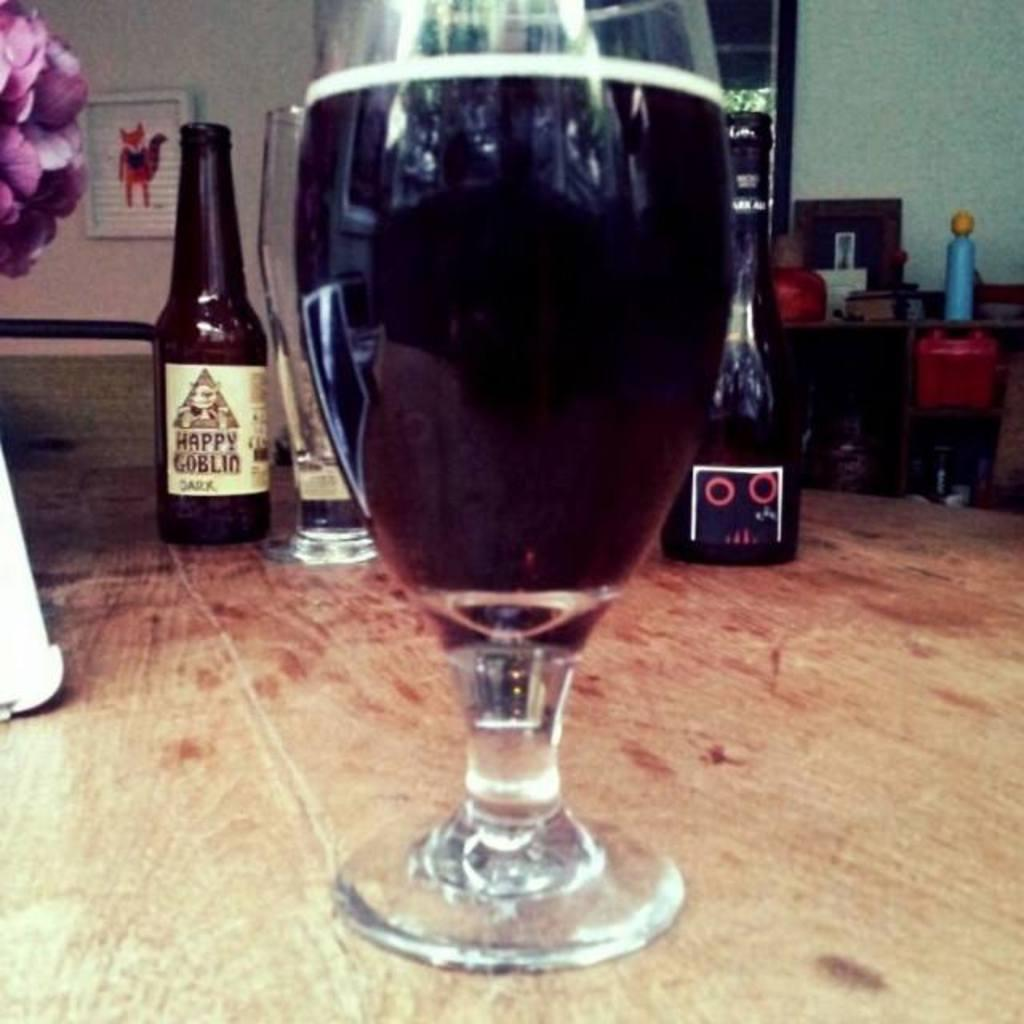What type of containers are present in the image? There are bottles in the image. What type of glassware is present in the image? There is a wine glass in the image. Where are the bottles and wine glass located in the image? Both the bottles and the wine glass are on a table. What type of gun is present in the image? There is no gun present in the image. 